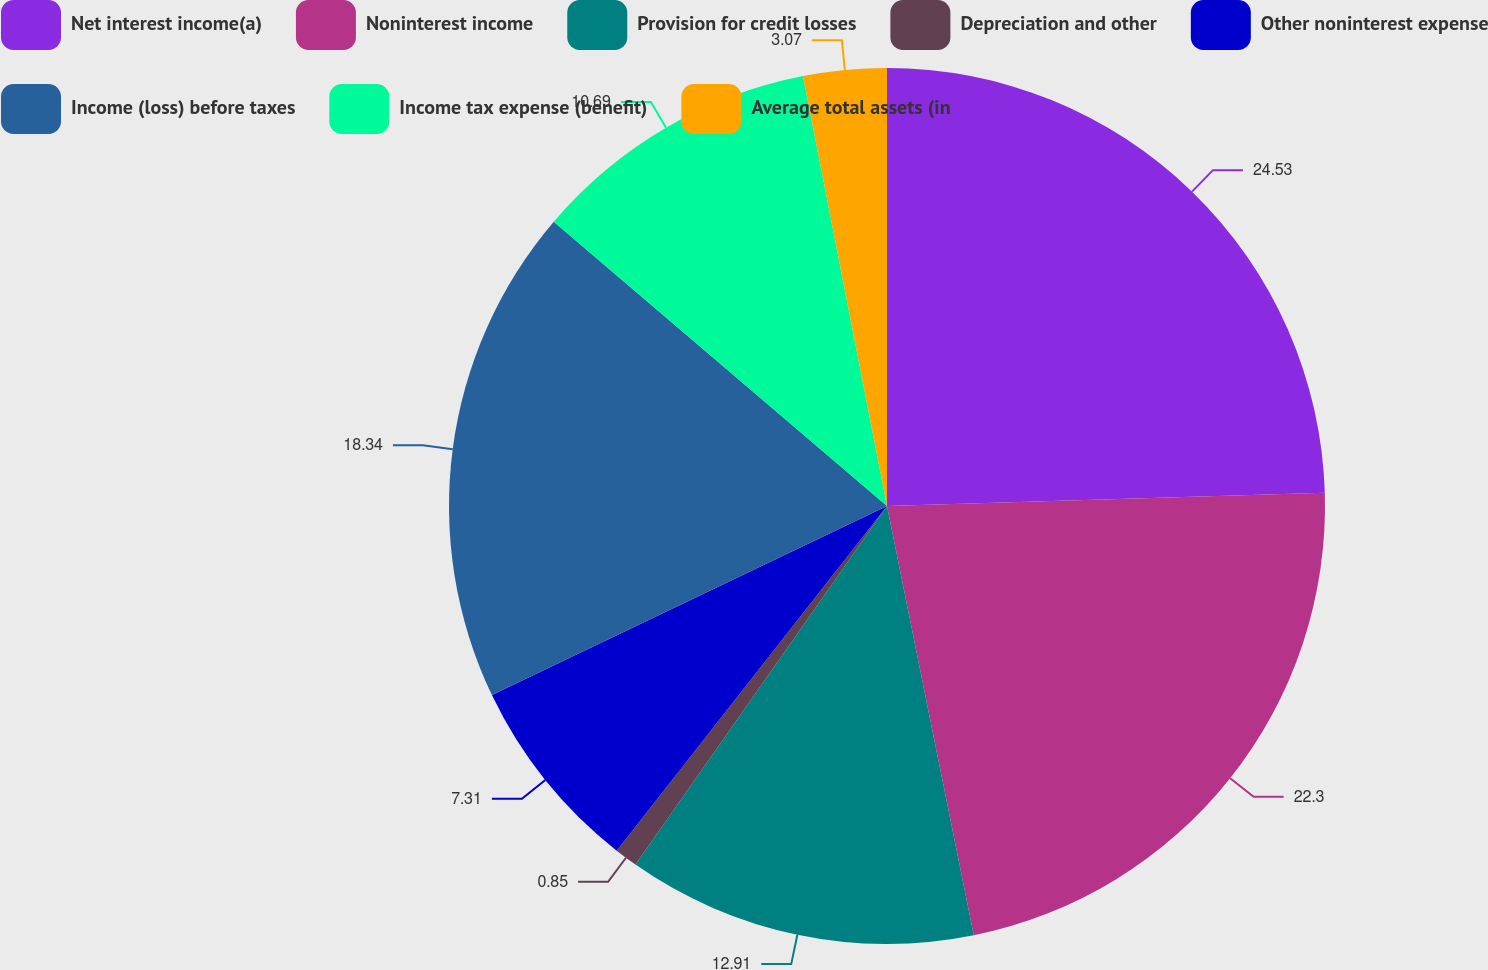Convert chart. <chart><loc_0><loc_0><loc_500><loc_500><pie_chart><fcel>Net interest income(a)<fcel>Noninterest income<fcel>Provision for credit losses<fcel>Depreciation and other<fcel>Other noninterest expense<fcel>Income (loss) before taxes<fcel>Income tax expense (benefit)<fcel>Average total assets (in<nl><fcel>24.52%<fcel>22.3%<fcel>12.91%<fcel>0.85%<fcel>7.31%<fcel>18.34%<fcel>10.69%<fcel>3.07%<nl></chart> 